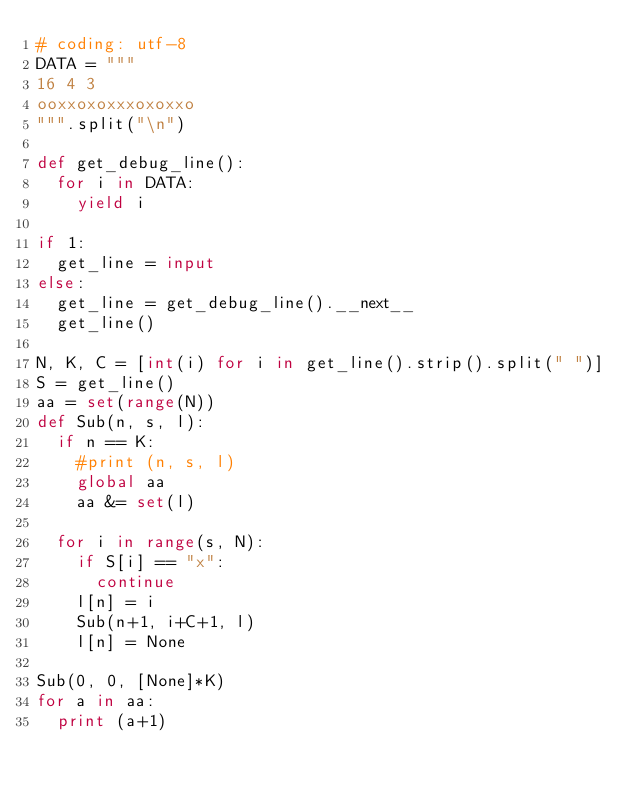<code> <loc_0><loc_0><loc_500><loc_500><_Python_># coding: utf-8
DATA = """
16 4 3
ooxxoxoxxxoxoxxo
""".split("\n")

def get_debug_line():
	for i in DATA:
		yield i

if 1:
	get_line = input
else:
	get_line = get_debug_line().__next__
	get_line()

N, K, C = [int(i) for i in get_line().strip().split(" ")]
S = get_line()
aa = set(range(N))
def Sub(n, s, l):
	if n == K:
		#print (n, s, l)
		global aa
		aa &= set(l)

	for i in range(s, N):
		if S[i] == "x":
			continue
		l[n] = i 
		Sub(n+1, i+C+1, l)
		l[n] = None

Sub(0, 0, [None]*K)
for a in aa:
	print (a+1)
</code> 